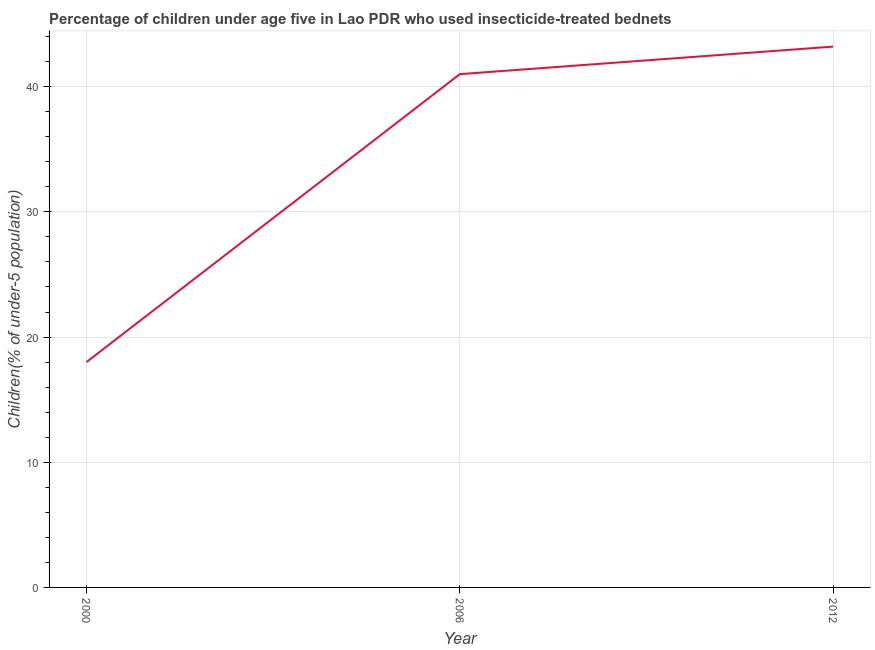What is the percentage of children who use of insecticide-treated bed nets in 2012?
Provide a short and direct response. 43.2. Across all years, what is the maximum percentage of children who use of insecticide-treated bed nets?
Your answer should be compact. 43.2. Across all years, what is the minimum percentage of children who use of insecticide-treated bed nets?
Keep it short and to the point. 18. In which year was the percentage of children who use of insecticide-treated bed nets maximum?
Offer a terse response. 2012. What is the sum of the percentage of children who use of insecticide-treated bed nets?
Ensure brevity in your answer.  102.2. What is the difference between the percentage of children who use of insecticide-treated bed nets in 2000 and 2012?
Ensure brevity in your answer.  -25.2. What is the average percentage of children who use of insecticide-treated bed nets per year?
Provide a short and direct response. 34.07. Do a majority of the years between 2006 and 2012 (inclusive) have percentage of children who use of insecticide-treated bed nets greater than 28 %?
Your answer should be very brief. Yes. What is the ratio of the percentage of children who use of insecticide-treated bed nets in 2000 to that in 2006?
Provide a short and direct response. 0.44. What is the difference between the highest and the second highest percentage of children who use of insecticide-treated bed nets?
Offer a terse response. 2.2. Is the sum of the percentage of children who use of insecticide-treated bed nets in 2000 and 2006 greater than the maximum percentage of children who use of insecticide-treated bed nets across all years?
Your answer should be very brief. Yes. What is the difference between the highest and the lowest percentage of children who use of insecticide-treated bed nets?
Your answer should be compact. 25.2. In how many years, is the percentage of children who use of insecticide-treated bed nets greater than the average percentage of children who use of insecticide-treated bed nets taken over all years?
Offer a terse response. 2. How many lines are there?
Provide a succinct answer. 1. How many years are there in the graph?
Ensure brevity in your answer.  3. Are the values on the major ticks of Y-axis written in scientific E-notation?
Your response must be concise. No. Does the graph contain any zero values?
Ensure brevity in your answer.  No. Does the graph contain grids?
Your response must be concise. Yes. What is the title of the graph?
Keep it short and to the point. Percentage of children under age five in Lao PDR who used insecticide-treated bednets. What is the label or title of the X-axis?
Ensure brevity in your answer.  Year. What is the label or title of the Y-axis?
Provide a succinct answer. Children(% of under-5 population). What is the Children(% of under-5 population) of 2000?
Give a very brief answer. 18. What is the Children(% of under-5 population) of 2012?
Make the answer very short. 43.2. What is the difference between the Children(% of under-5 population) in 2000 and 2006?
Your response must be concise. -23. What is the difference between the Children(% of under-5 population) in 2000 and 2012?
Your answer should be very brief. -25.2. What is the difference between the Children(% of under-5 population) in 2006 and 2012?
Ensure brevity in your answer.  -2.2. What is the ratio of the Children(% of under-5 population) in 2000 to that in 2006?
Your answer should be compact. 0.44. What is the ratio of the Children(% of under-5 population) in 2000 to that in 2012?
Your answer should be very brief. 0.42. What is the ratio of the Children(% of under-5 population) in 2006 to that in 2012?
Your answer should be very brief. 0.95. 